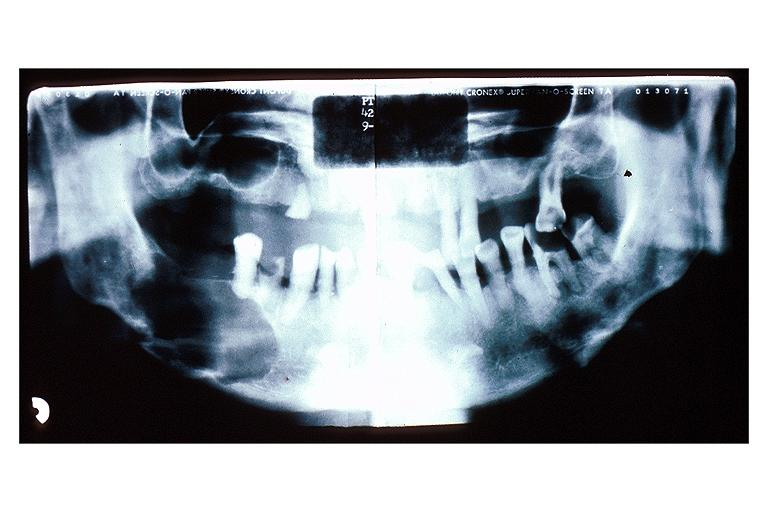does nodule show multiple myeloma?
Answer the question using a single word or phrase. No 